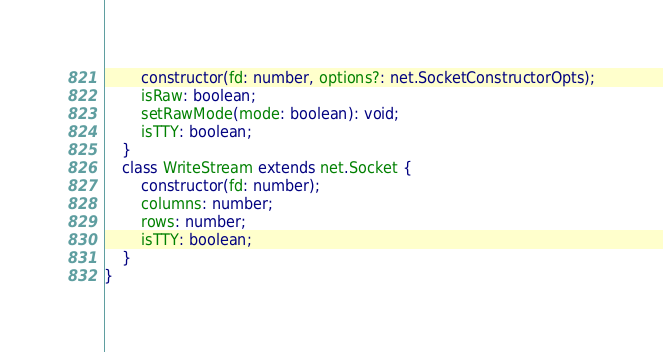<code> <loc_0><loc_0><loc_500><loc_500><_TypeScript_>        constructor(fd: number, options?: net.SocketConstructorOpts);
        isRaw: boolean;
        setRawMode(mode: boolean): void;
        isTTY: boolean;
    }
    class WriteStream extends net.Socket {
        constructor(fd: number);
        columns: number;
        rows: number;
        isTTY: boolean;
    }
}
</code> 